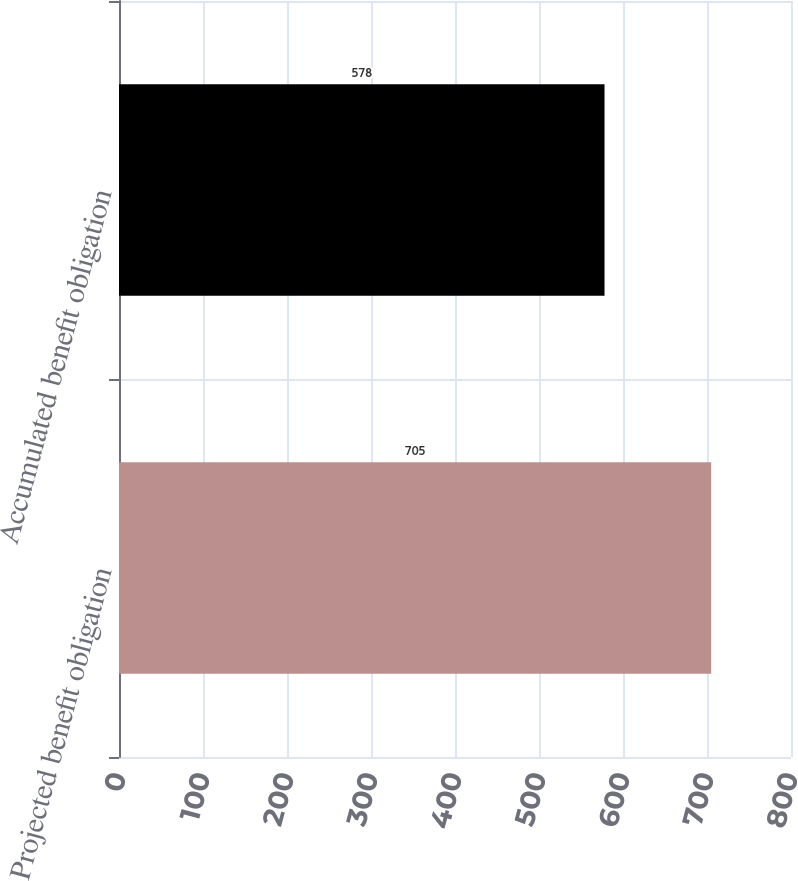Convert chart. <chart><loc_0><loc_0><loc_500><loc_500><bar_chart><fcel>Projected benefit obligation<fcel>Accumulated benefit obligation<nl><fcel>705<fcel>578<nl></chart> 